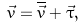Convert formula to latex. <formula><loc_0><loc_0><loc_500><loc_500>\vec { v } = \overline { \vec { v } } + \vec { \tau } ,</formula> 